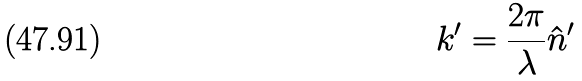<formula> <loc_0><loc_0><loc_500><loc_500>k ^ { \prime } = \frac { 2 \pi } { \lambda } \hat { n } ^ { \prime }</formula> 